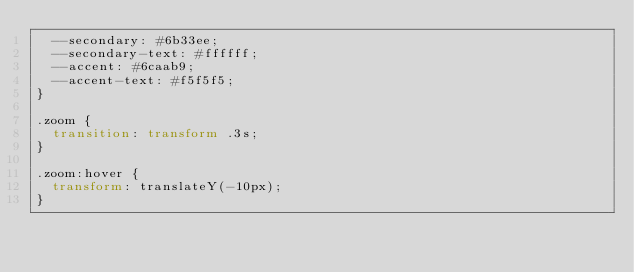Convert code to text. <code><loc_0><loc_0><loc_500><loc_500><_CSS_>  --secondary: #6b33ee;
  --secondary-text: #ffffff;
  --accent: #6caab9;
  --accent-text: #f5f5f5;
}

.zoom {
  transition: transform .3s;
}

.zoom:hover {
  transform: translateY(-10px);
}
</code> 